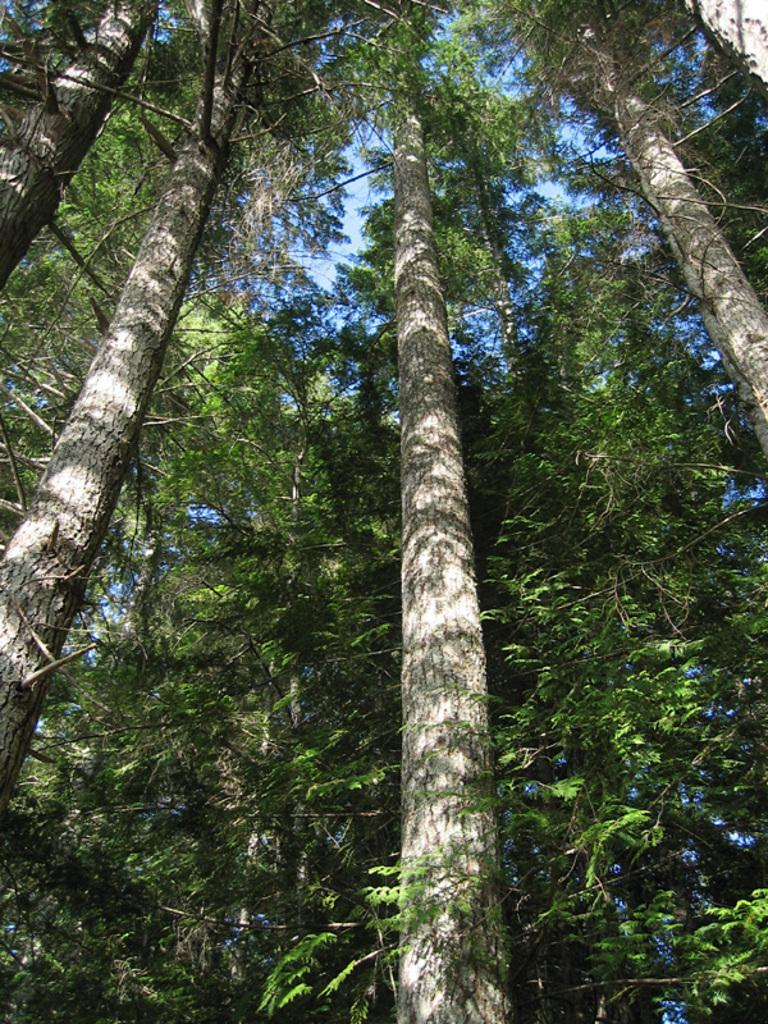What type of vegetation can be seen in the image? There are trees in the image. What is visible behind the trees in the image? The sky is visible behind the trees in the image. What type of skirt is hanging from the tree in the image? There is no skirt present in the image; it only features trees and the sky. What type of pollution can be seen in the image? There is no pollution visible in the image; it only features trees and the sky. 